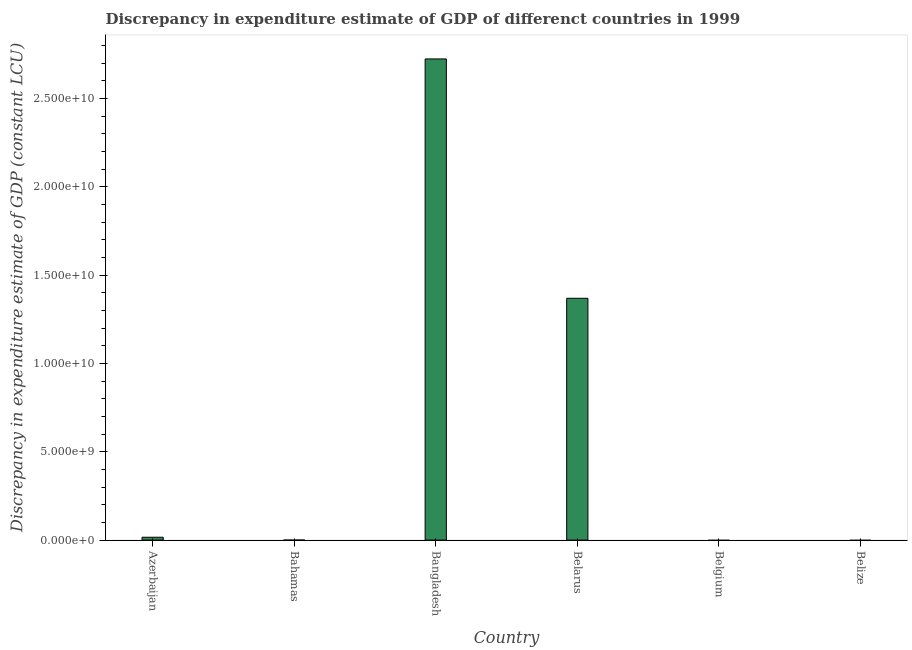What is the title of the graph?
Offer a very short reply. Discrepancy in expenditure estimate of GDP of differenct countries in 1999. What is the label or title of the X-axis?
Offer a terse response. Country. What is the label or title of the Y-axis?
Offer a very short reply. Discrepancy in expenditure estimate of GDP (constant LCU). What is the discrepancy in expenditure estimate of gdp in Bahamas?
Provide a succinct answer. 2000. Across all countries, what is the maximum discrepancy in expenditure estimate of gdp?
Your response must be concise. 2.72e+1. What is the sum of the discrepancy in expenditure estimate of gdp?
Your answer should be very brief. 4.11e+1. What is the difference between the discrepancy in expenditure estimate of gdp in Bahamas and Belarus?
Provide a short and direct response. -1.37e+1. What is the average discrepancy in expenditure estimate of gdp per country?
Your answer should be very brief. 6.85e+09. What is the median discrepancy in expenditure estimate of gdp?
Your answer should be very brief. 8.09e+07. In how many countries, is the discrepancy in expenditure estimate of gdp greater than 27000000000 LCU?
Make the answer very short. 1. What is the ratio of the discrepancy in expenditure estimate of gdp in Azerbaijan to that in Belarus?
Your response must be concise. 0.01. Is the difference between the discrepancy in expenditure estimate of gdp in Azerbaijan and Bangladesh greater than the difference between any two countries?
Your answer should be very brief. No. What is the difference between the highest and the second highest discrepancy in expenditure estimate of gdp?
Make the answer very short. 1.36e+1. Is the sum of the discrepancy in expenditure estimate of gdp in Bangladesh and Belarus greater than the maximum discrepancy in expenditure estimate of gdp across all countries?
Offer a very short reply. Yes. What is the difference between the highest and the lowest discrepancy in expenditure estimate of gdp?
Provide a short and direct response. 2.72e+1. In how many countries, is the discrepancy in expenditure estimate of gdp greater than the average discrepancy in expenditure estimate of gdp taken over all countries?
Your response must be concise. 2. How many bars are there?
Make the answer very short. 4. Are all the bars in the graph horizontal?
Offer a terse response. No. Are the values on the major ticks of Y-axis written in scientific E-notation?
Keep it short and to the point. Yes. What is the Discrepancy in expenditure estimate of GDP (constant LCU) in Azerbaijan?
Make the answer very short. 1.62e+08. What is the Discrepancy in expenditure estimate of GDP (constant LCU) of Bangladesh?
Ensure brevity in your answer.  2.72e+1. What is the Discrepancy in expenditure estimate of GDP (constant LCU) of Belarus?
Provide a succinct answer. 1.37e+1. What is the Discrepancy in expenditure estimate of GDP (constant LCU) in Belgium?
Your answer should be very brief. 0. What is the difference between the Discrepancy in expenditure estimate of GDP (constant LCU) in Azerbaijan and Bahamas?
Offer a terse response. 1.62e+08. What is the difference between the Discrepancy in expenditure estimate of GDP (constant LCU) in Azerbaijan and Bangladesh?
Keep it short and to the point. -2.71e+1. What is the difference between the Discrepancy in expenditure estimate of GDP (constant LCU) in Azerbaijan and Belarus?
Offer a terse response. -1.35e+1. What is the difference between the Discrepancy in expenditure estimate of GDP (constant LCU) in Bahamas and Bangladesh?
Make the answer very short. -2.72e+1. What is the difference between the Discrepancy in expenditure estimate of GDP (constant LCU) in Bahamas and Belarus?
Provide a short and direct response. -1.37e+1. What is the difference between the Discrepancy in expenditure estimate of GDP (constant LCU) in Bangladesh and Belarus?
Give a very brief answer. 1.36e+1. What is the ratio of the Discrepancy in expenditure estimate of GDP (constant LCU) in Azerbaijan to that in Bahamas?
Provide a short and direct response. 8.09e+04. What is the ratio of the Discrepancy in expenditure estimate of GDP (constant LCU) in Azerbaijan to that in Bangladesh?
Keep it short and to the point. 0.01. What is the ratio of the Discrepancy in expenditure estimate of GDP (constant LCU) in Azerbaijan to that in Belarus?
Keep it short and to the point. 0.01. What is the ratio of the Discrepancy in expenditure estimate of GDP (constant LCU) in Bahamas to that in Belarus?
Make the answer very short. 0. What is the ratio of the Discrepancy in expenditure estimate of GDP (constant LCU) in Bangladesh to that in Belarus?
Ensure brevity in your answer.  1.99. 